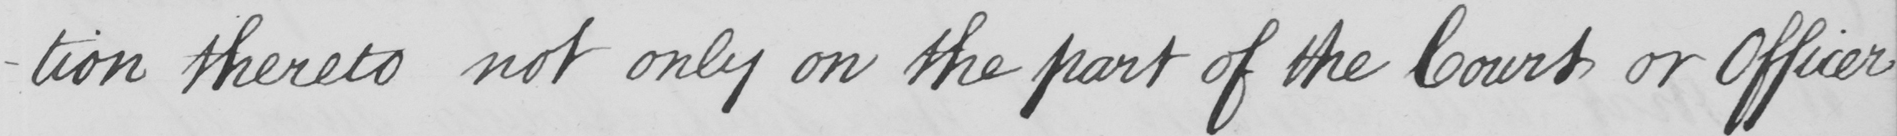What is written in this line of handwriting? -tion thereto not only on the part of the Court or Officer 